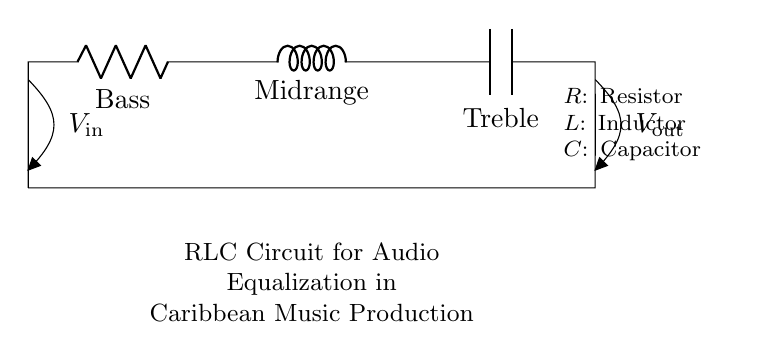What does the resistor represent in this circuit? The resistor is labeled as "Bass," indicating it controls the bass frequencies in the audio signal.
Answer: Bass What is the role of the inductor in this circuit? The inductor is labeled "Midrange," showing that it is used to manage midrange frequencies in the audio signal.
Answer: Midrange What component is used for treble frequencies? The capacitor is labeled "Treble," which means it is responsible for treble frequencies in the audio signal.
Answer: Treble How many components are in this RLC circuit? The diagram shows three components: a resistor, an inductor, and a capacitor, making a total of three components.
Answer: Three What is the voltage input to the circuit? The diagram labels the input voltage as "Vin," which signifies the voltage supplied to the circuit.
Answer: Vin How does the current flow in this circuit? Current flows from the input voltage (Vin) through the resistor, then the inductor, and finally the capacitor before returning to the circuit, indicating a series configuration.
Answer: Series What is an application of this RLC circuit in music production? This RLC circuit is used for audio equalization, specifically to adjust frequency ranges that enhance Caribbean music production.
Answer: Audio equalization 